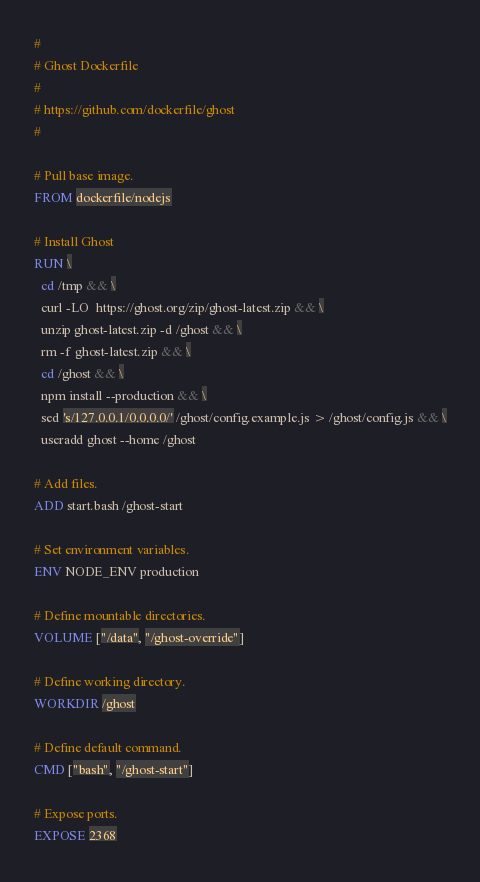<code> <loc_0><loc_0><loc_500><loc_500><_Dockerfile_>#
# Ghost Dockerfile
#
# https://github.com/dockerfile/ghost
#

# Pull base image.
FROM dockerfile/nodejs

# Install Ghost
RUN \
  cd /tmp && \
  curl -LO  https://ghost.org/zip/ghost-latest.zip && \
  unzip ghost-latest.zip -d /ghost && \
  rm -f ghost-latest.zip && \
  cd /ghost && \
  npm install --production && \
  sed 's/127.0.0.1/0.0.0.0/' /ghost/config.example.js > /ghost/config.js && \
  useradd ghost --home /ghost

# Add files.
ADD start.bash /ghost-start

# Set environment variables.
ENV NODE_ENV production

# Define mountable directories.
VOLUME ["/data", "/ghost-override"]

# Define working directory.
WORKDIR /ghost

# Define default command.
CMD ["bash", "/ghost-start"]

# Expose ports.
EXPOSE 2368
</code> 